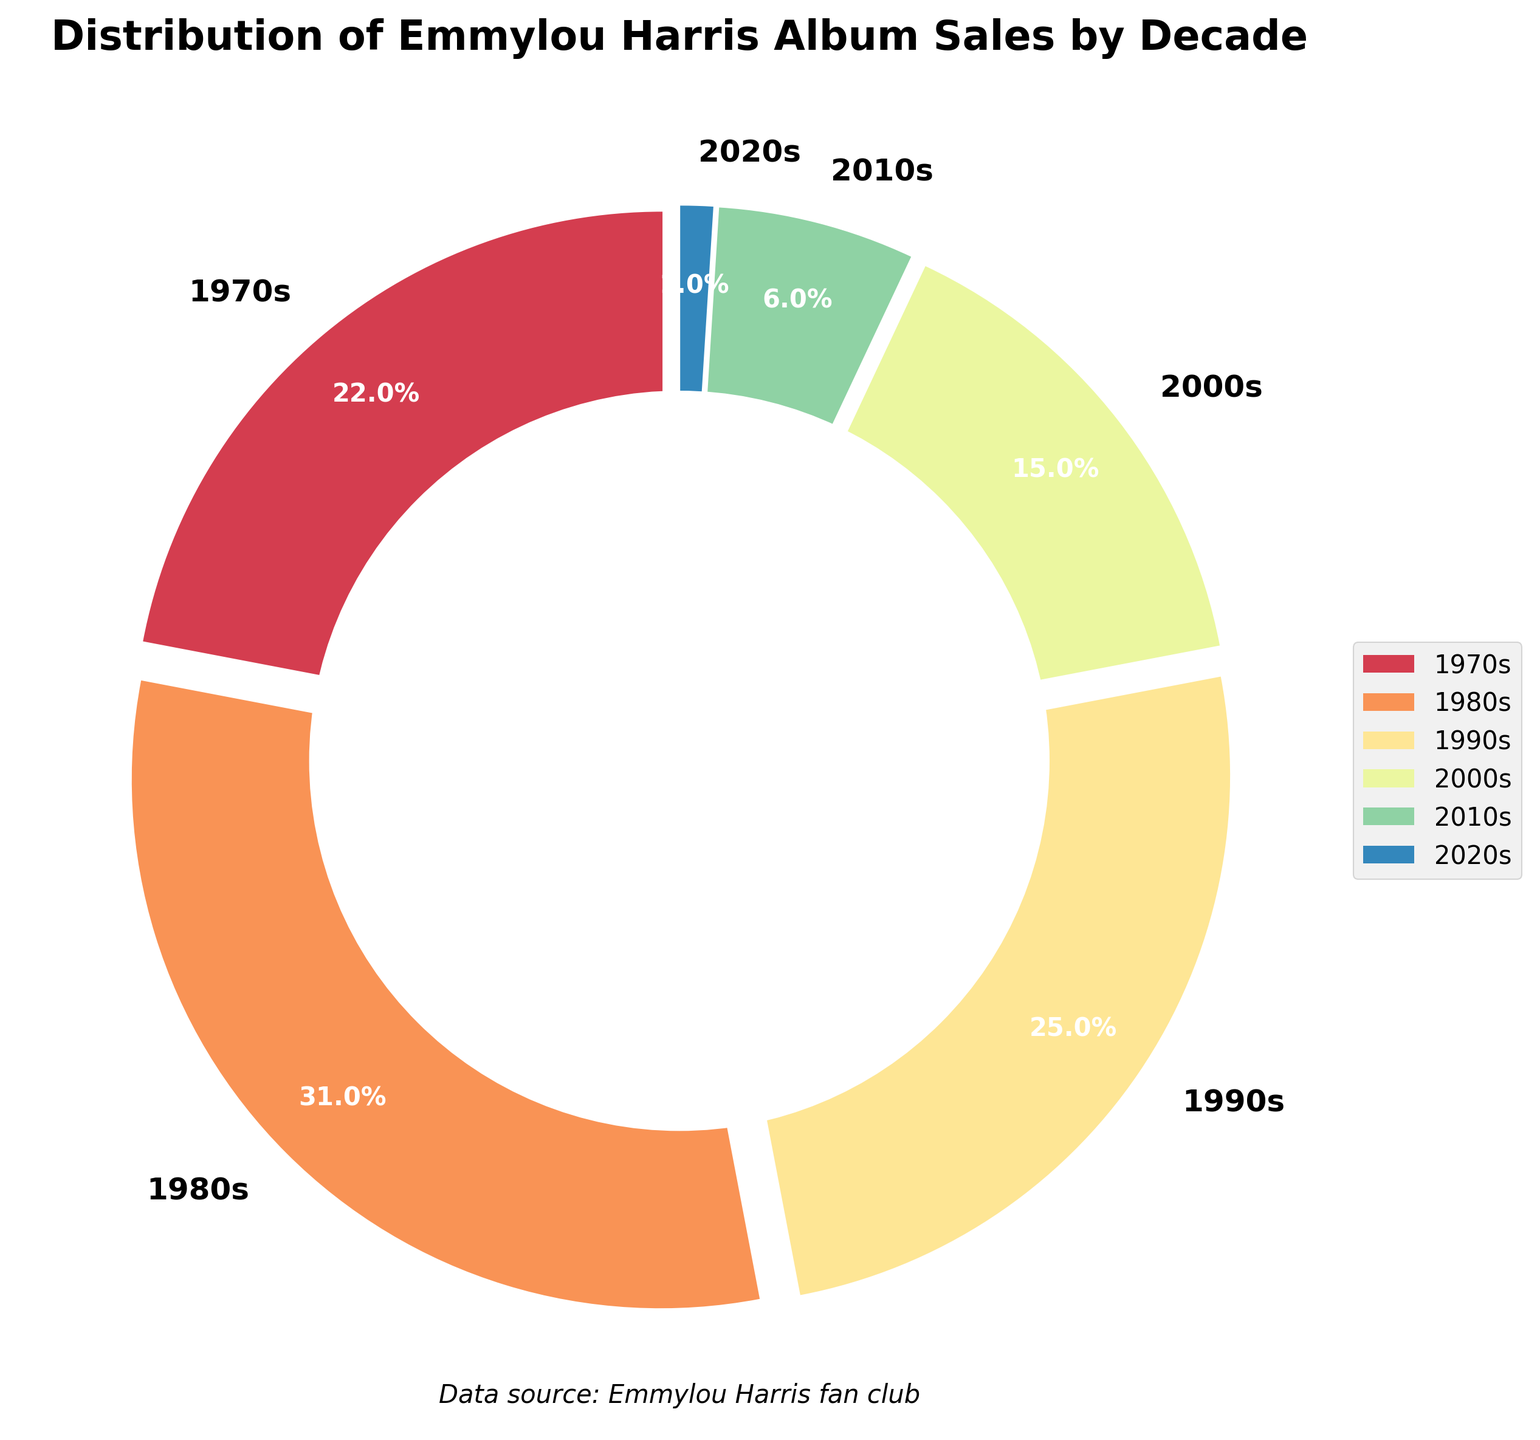What percentage of Emmylou Harris's album sales occurred in the 2000s? Find the segment labeled '2000s' in the pie chart and refer to the percentage listed.
Answer: 15% Which decade had the highest album sales percentage? Look for the largest segment in the pie chart and check its label. The '1980s' segment is the largest.
Answer: 1980s By how much is the album sales percentage in the 1980s greater than in the 2010s? Find the percentages for the 1980s and 2010s, then subtract the 2010s percentage from the 1980s percentage: 31% - 6% = 25%.
Answer: 25% What is the combined album sales percentage for the decades 1970s and 1990s? Add the percentages of the two decades: 22% (1970s) + 25% (1990s) = 47%.
Answer: 47% Which decade has the smallest album sales percentage, and what is that percentage? Find the smallest segment in the pie chart and check its label and percentage. The smallest segment is labeled '2020s' with 1%.
Answer: 2020s, 1% Is the album sales percentage in the 1970s greater than in the 2010s? Compare the percentages for the two decades. For the 1970s, it is 22%, while for the 2010s, it is 6%. Since 22% > 6%, the 1970s percentage is greater.
Answer: Yes In which color is the 1980s segment represented? Locate the color of the largest segment in the pie chart, which corresponds to the 1980s.
Answer: Please refer to the specific color used in the figure since colors may vary What are the total album sales percentages for the decades after the 1990s? Add the percentages of the 2000s, 2010s, and 2020s: 15% + 6% + 1% = 22%.
Answer: 22% Which decade has the second highest album sales percentage, and what is that percentage? Identify the second largest segment in the pie chart. The 1990s segment is second largest with 25%.
Answer: 1990s, 25% What’s the difference between the album sales percentages of the 1970s and the 2000s? Subtract the 2000s percentage from the 1970s percentage: 22% - 15% = 7%.
Answer: 7% 